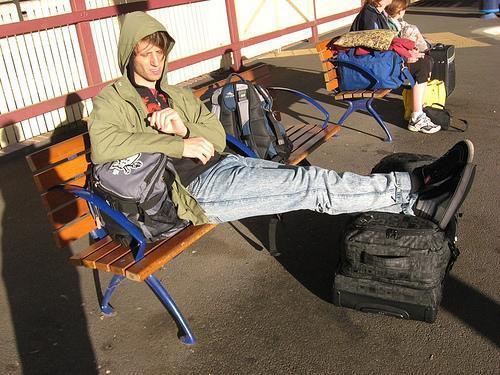How many suitcases can you see?
Give a very brief answer. 3. How many people can be seen?
Give a very brief answer. 2. How many backpacks are there?
Give a very brief answer. 2. 